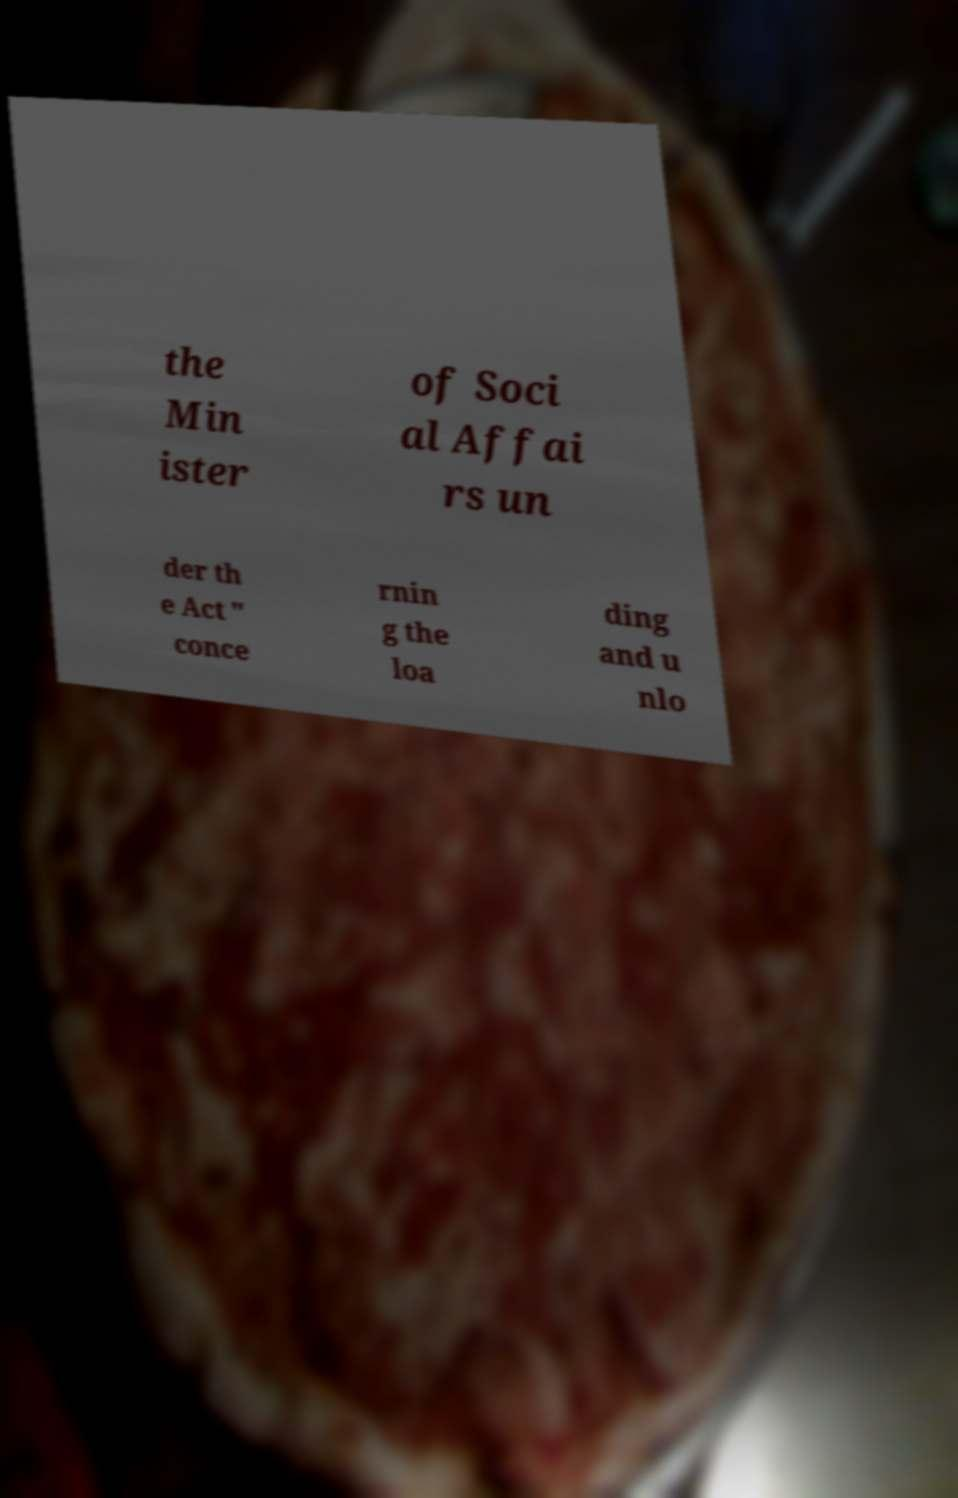Could you assist in decoding the text presented in this image and type it out clearly? the Min ister of Soci al Affai rs un der th e Act " conce rnin g the loa ding and u nlo 